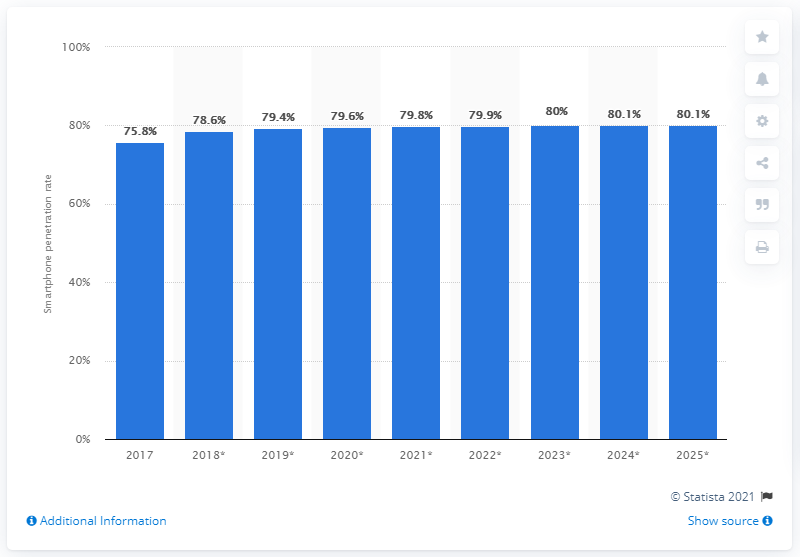Indicate a few pertinent items in this graphic. By 2025, it was estimated that 80.1% of Australians would be using smartphones. 